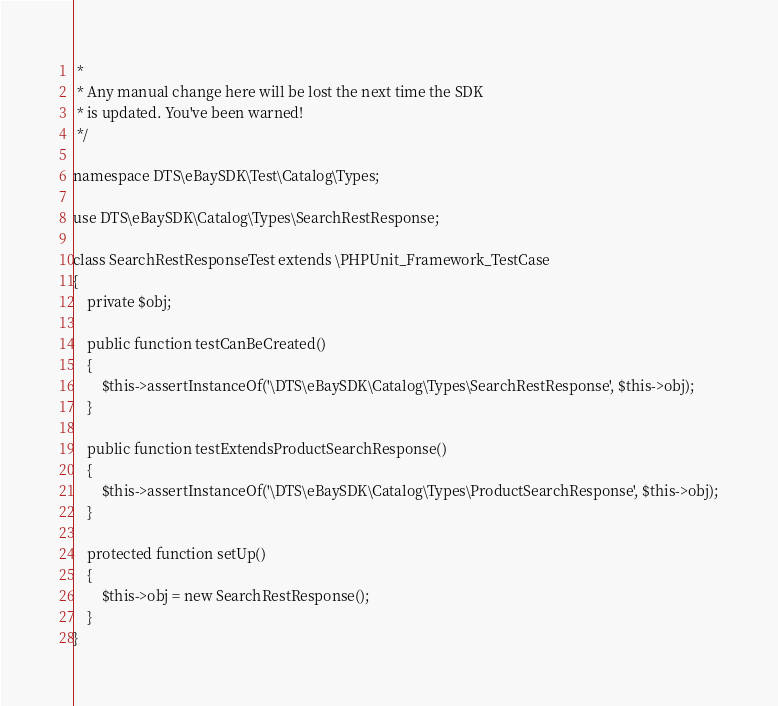<code> <loc_0><loc_0><loc_500><loc_500><_PHP_> *
 * Any manual change here will be lost the next time the SDK
 * is updated. You've been warned!
 */

namespace DTS\eBaySDK\Test\Catalog\Types;

use DTS\eBaySDK\Catalog\Types\SearchRestResponse;

class SearchRestResponseTest extends \PHPUnit_Framework_TestCase
{
    private $obj;

    public function testCanBeCreated()
    {
        $this->assertInstanceOf('\DTS\eBaySDK\Catalog\Types\SearchRestResponse', $this->obj);
    }

    public function testExtendsProductSearchResponse()
    {
        $this->assertInstanceOf('\DTS\eBaySDK\Catalog\Types\ProductSearchResponse', $this->obj);
    }

    protected function setUp()
    {
        $this->obj = new SearchRestResponse();
    }
}
</code> 